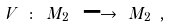Convert formula to latex. <formula><loc_0><loc_0><loc_500><loc_500>V \ \colon \ M _ { 2 } \ \longrightarrow \ M _ { 2 } \ ,</formula> 